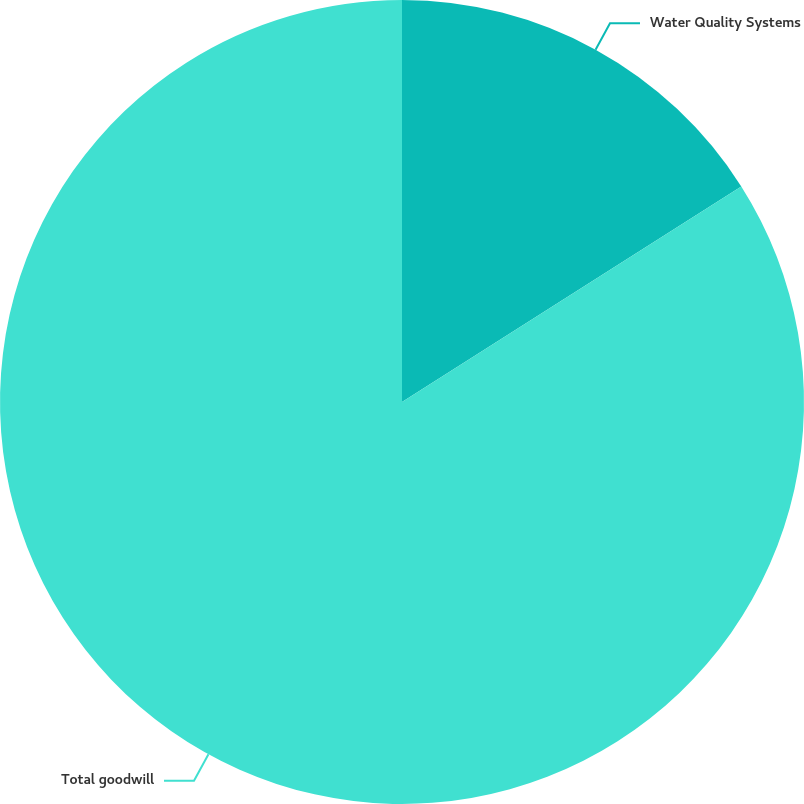Convert chart. <chart><loc_0><loc_0><loc_500><loc_500><pie_chart><fcel>Water Quality Systems<fcel>Total goodwill<nl><fcel>15.99%<fcel>84.01%<nl></chart> 